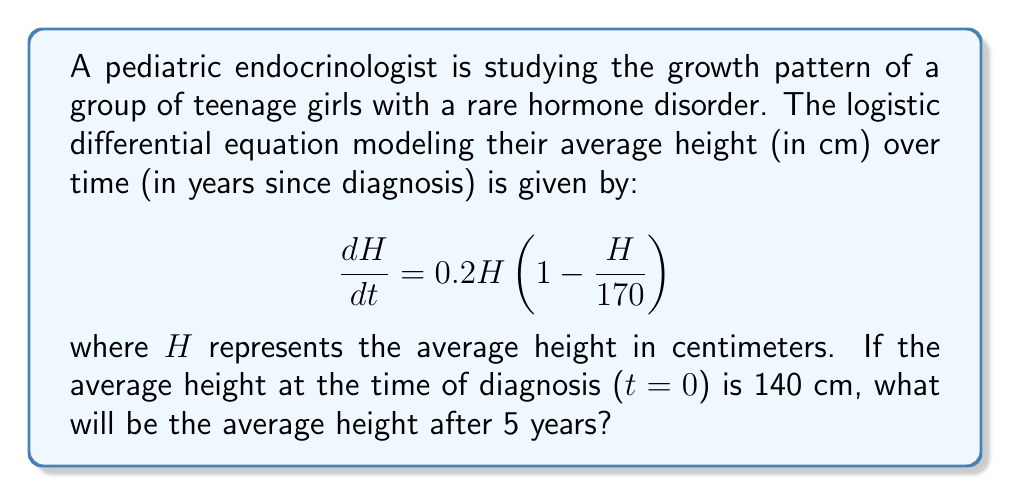What is the answer to this math problem? To solve this problem, we need to use the logistic growth model and its solution. The general form of the logistic differential equation is:

$$\frac{dP}{dt} = rP(1 - \frac{P}{K})$$

where $r$ is the growth rate and $K$ is the carrying capacity.

In our case, $r = 0.2$ and $K = 170$ cm.

The solution to the logistic differential equation is:

$$P(t) = \frac{KP_0}{P_0 + (K-P_0)e^{-rt}}$$

where $P_0$ is the initial population (or in this case, initial height).

Let's plug in our values:
$K = 170$ cm
$r = 0.2$
$P_0 = H_0 = 140$ cm
$t = 5$ years

$$H(5) = \frac{170 \cdot 140}{140 + (170-140)e^{-0.2 \cdot 5}}$$

$$H(5) = \frac{23800}{140 + 30e^{-1}}$$

$$H(5) = \frac{23800}{140 + 30 \cdot 0.3679}$$

$$H(5) = \frac{23800}{151.037}$$

$$H(5) \approx 157.58$$

Therefore, after 5 years, the average height of the girls will be approximately 157.58 cm.
Answer: 157.58 cm 